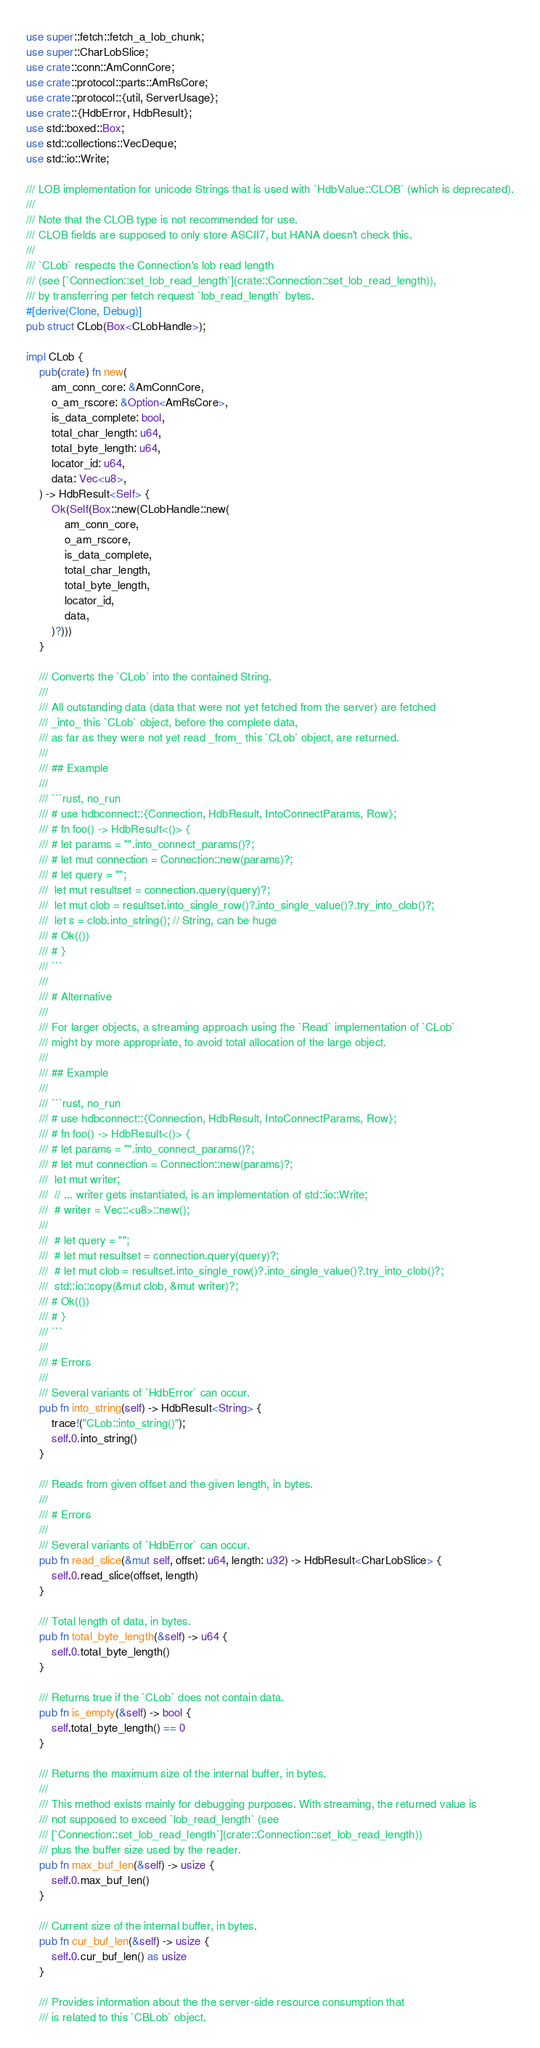<code> <loc_0><loc_0><loc_500><loc_500><_Rust_>use super::fetch::fetch_a_lob_chunk;
use super::CharLobSlice;
use crate::conn::AmConnCore;
use crate::protocol::parts::AmRsCore;
use crate::protocol::{util, ServerUsage};
use crate::{HdbError, HdbResult};
use std::boxed::Box;
use std::collections::VecDeque;
use std::io::Write;

/// LOB implementation for unicode Strings that is used with `HdbValue::CLOB` (which is deprecated).
///
/// Note that the CLOB type is not recommended for use.
/// CLOB fields are supposed to only store ASCII7, but HANA doesn't check this.
///
/// `CLob` respects the Connection's lob read length
/// (see [`Connection::set_lob_read_length`](crate::Connection::set_lob_read_length)),
/// by transferring per fetch request `lob_read_length` bytes.
#[derive(Clone, Debug)]
pub struct CLob(Box<CLobHandle>);

impl CLob {
    pub(crate) fn new(
        am_conn_core: &AmConnCore,
        o_am_rscore: &Option<AmRsCore>,
        is_data_complete: bool,
        total_char_length: u64,
        total_byte_length: u64,
        locator_id: u64,
        data: Vec<u8>,
    ) -> HdbResult<Self> {
        Ok(Self(Box::new(CLobHandle::new(
            am_conn_core,
            o_am_rscore,
            is_data_complete,
            total_char_length,
            total_byte_length,
            locator_id,
            data,
        )?)))
    }

    /// Converts the `CLob` into the contained String.
    ///
    /// All outstanding data (data that were not yet fetched from the server) are fetched
    /// _into_ this `CLob` object, before the complete data,
    /// as far as they were not yet read _from_ this `CLob` object, are returned.
    ///
    /// ## Example
    ///
    /// ```rust, no_run
    /// # use hdbconnect::{Connection, HdbResult, IntoConnectParams, Row};
    /// # fn foo() -> HdbResult<()> {
    /// # let params = "".into_connect_params()?;
    /// # let mut connection = Connection::new(params)?;
    /// # let query = "";
    ///  let mut resultset = connection.query(query)?;
    ///  let mut clob = resultset.into_single_row()?.into_single_value()?.try_into_clob()?;
    ///  let s = clob.into_string(); // String, can be huge
    /// # Ok(())
    /// # }
    /// ```
    ///
    /// # Alternative
    ///
    /// For larger objects, a streaming approach using the `Read` implementation of `CLob`
    /// might by more appropriate, to avoid total allocation of the large object.
    ///
    /// ## Example
    ///
    /// ```rust, no_run
    /// # use hdbconnect::{Connection, HdbResult, IntoConnectParams, Row};
    /// # fn foo() -> HdbResult<()> {
    /// # let params = "".into_connect_params()?;
    /// # let mut connection = Connection::new(params)?;
    ///  let mut writer;
    ///  // ... writer gets instantiated, is an implementation of std::io::Write;
    ///  # writer = Vec::<u8>::new();
    ///
    ///  # let query = "";
    ///  # let mut resultset = connection.query(query)?;
    ///  # let mut clob = resultset.into_single_row()?.into_single_value()?.try_into_clob()?;
    ///  std::io::copy(&mut clob, &mut writer)?;
    /// # Ok(())
    /// # }
    /// ```
    ///
    /// # Errors
    ///
    /// Several variants of `HdbError` can occur.
    pub fn into_string(self) -> HdbResult<String> {
        trace!("CLob::into_string()");
        self.0.into_string()
    }

    /// Reads from given offset and the given length, in bytes.
    ///
    /// # Errors
    ///
    /// Several variants of `HdbError` can occur.
    pub fn read_slice(&mut self, offset: u64, length: u32) -> HdbResult<CharLobSlice> {
        self.0.read_slice(offset, length)
    }

    /// Total length of data, in bytes.
    pub fn total_byte_length(&self) -> u64 {
        self.0.total_byte_length()
    }

    /// Returns true if the `CLob` does not contain data.
    pub fn is_empty(&self) -> bool {
        self.total_byte_length() == 0
    }

    /// Returns the maximum size of the internal buffer, in bytes.
    ///
    /// This method exists mainly for debugging purposes. With streaming, the returned value is
    /// not supposed to exceed `lob_read_length` (see
    /// [`Connection::set_lob_read_length`](crate::Connection::set_lob_read_length))
    /// plus the buffer size used by the reader.
    pub fn max_buf_len(&self) -> usize {
        self.0.max_buf_len()
    }

    /// Current size of the internal buffer, in bytes.
    pub fn cur_buf_len(&self) -> usize {
        self.0.cur_buf_len() as usize
    }

    /// Provides information about the the server-side resource consumption that
    /// is related to this `CBLob` object.</code> 